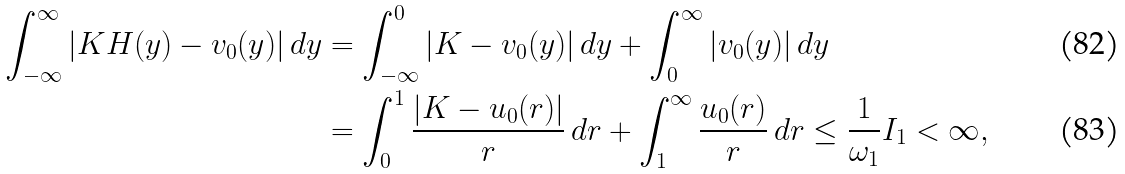<formula> <loc_0><loc_0><loc_500><loc_500>\int _ { - \infty } ^ { \infty } | K H ( y ) - v _ { 0 } ( y ) | \, d y & = \int _ { - \infty } ^ { 0 } | K - v _ { 0 } ( y ) | \, d y + \int _ { 0 } ^ { \infty } | v _ { 0 } ( y ) | \, d y \\ & = \int _ { 0 } ^ { 1 } \frac { | K - u _ { 0 } ( r ) | } { r } \, d r + \int _ { 1 } ^ { \infty } \frac { u _ { 0 } ( r ) } { r } \, d r \leq \frac { 1 } { \omega _ { 1 } } I _ { 1 } < \infty ,</formula> 